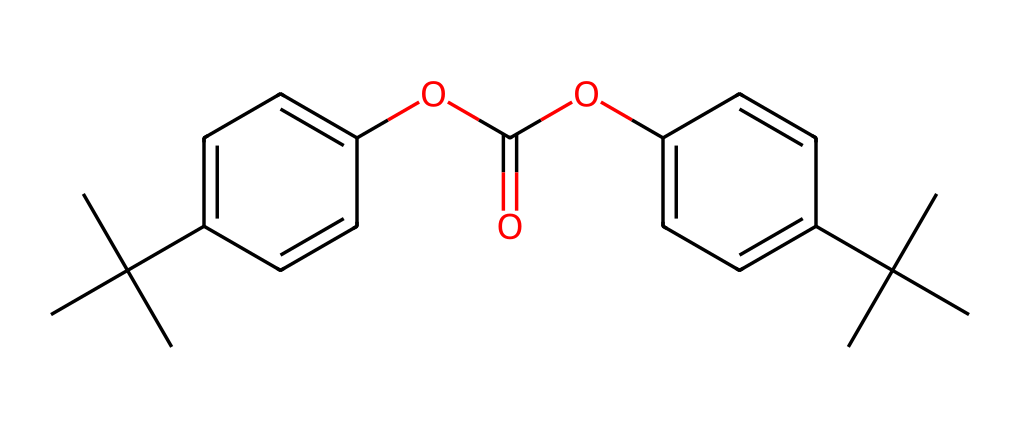What is the main functional group present in the chemical? The chemical structure contains an ester functional group, which can be identified by the presence of a carbonyl (C=O) bonded to an alkoxy group (OC). This is visible in the part of the SMILES representation where the "OC(=O)" segment appears.
Answer: ester How many aromatic rings are present in the structure? By analyzing the SMILES representation, we can see that it contains two "c" (aromatic carbon) clusters, indicating the presence of two aromatic rings. Each repetition of "c" signifies an aromatic carbon, thus giving us two rings in total.
Answer: two What is the molecular formula of this compound? To determine the molecular formula, we would count the carbon (C), hydrogen (H), and oxygen (O) atoms based on the SMILES string. Upon counting, we find there are 20 carbons, 30 hydrogens, and 4 oxygens present in the chemical structure.
Answer: C20H30O4 Which part of the chemical contributes to its plastic properties? The presence of the ester linkages in the structure typically enhances the polymerization, contributing to the plastic properties. The ester bonds allow for flexibility and durability, which are essential characteristics of polycarbonate plastics.
Answer: ester linkages Is this compound likely to be biodegradable? Generally, polycarbonate plastics are not biodegradable due to their stable molecular structure, particularly the presence of strong covalent bonds that resist breakdown by environmental conditions. This can be deduced from the presence of the aromatic rings and ester functional groups which make it robust.
Answer: no What is the significance of the tert-butyl groups in the structure? The tert-butyl groups, indicated as "C(C)(C)" in the SMILES, contribute to the bulkiness and hydrophobic character of the polymer. This addition can enhance impact resistance in polycarbonate materials, making them suitable for applications in demanding environments such as tattoo machines.
Answer: impact resistance 